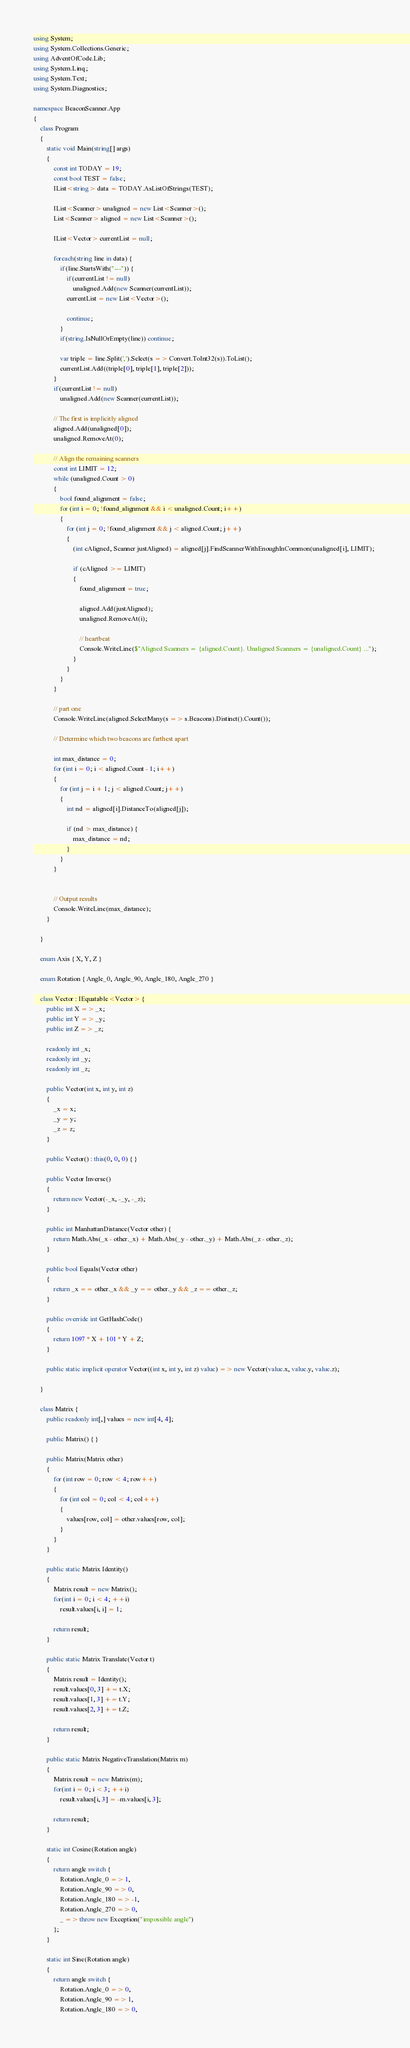Convert code to text. <code><loc_0><loc_0><loc_500><loc_500><_C#_>using System;
using System.Collections.Generic;
using AdventOfCode.Lib;
using System.Linq;
using System.Text;
using System.Diagnostics;

namespace BeaconScanner.App
{
    class Program
    {
        static void Main(string[] args)
        {
            const int TODAY = 19;
            const bool TEST = false;
            IList<string> data = TODAY.AsListOfStrings(TEST);

            IList<Scanner> unaligned = new List<Scanner>();
            List<Scanner> aligned = new List<Scanner>();

            IList<Vector> currentList = null;

            foreach(string line in data) {
                if(line.StartsWith("---")) {
                    if(currentList != null)
                        unaligned.Add(new Scanner(currentList));
                    currentList = new List<Vector>();
                    
                    continue;
                }
                if(string.IsNullOrEmpty(line)) continue;

                var triple = line.Split(',').Select(s => Convert.ToInt32(s)).ToList();
                currentList.Add((triple[0], triple[1], triple[2]));
            }
            if(currentList != null)
                unaligned.Add(new Scanner(currentList));

            // The first is implicitly aligned 
            aligned.Add(unaligned[0]);
            unaligned.RemoveAt(0);

            // Align the remaining scanners
            const int LIMIT = 12;
            while (unaligned.Count > 0)
            {
                bool found_alignment = false;
                for (int i = 0; !found_alignment && i < unaligned.Count; i++)
                {
                    for (int j = 0; !found_alignment && j < aligned.Count; j++)
                    {
                        (int cAligned, Scanner justAligned) = aligned[j].FindScannerWithEnoughInCommon(unaligned[i], LIMIT);

                        if (cAligned >= LIMIT)
                        {
                            found_alignment = true;

                            aligned.Add(justAligned);
                            unaligned.RemoveAt(i);

                            // heartbeat
                            Console.WriteLine($"Aligned Scanners = {aligned.Count}. Unaligned Scanners = {unaligned.Count} ...");
                        }
                    }
                }
            }

            // part one
            Console.WriteLine(aligned.SelectMany(s => s.Beacons).Distinct().Count());

            // Determine which two beacons are farthest apart

            int max_distance = 0;
            for (int i = 0; i < aligned.Count - 1; i++)
            {
                for (int j = i + 1; j < aligned.Count; j++)
                {
                    int nd = aligned[i].DistanceTo(aligned[j]);

                    if (nd > max_distance) {
                        max_distance = nd;
                    }
                }
            }


            // Output results
            Console.WriteLine(max_distance);
        }

    }

    enum Axis { X, Y, Z }

    enum Rotation { Angle_0, Angle_90, Angle_180, Angle_270 }
    
    class Vector : IEquatable<Vector> { 
        public int X => _x;
        public int Y => _y;
        public int Z => _z;
        
        readonly int _x;
        readonly int _y;
        readonly int _z;

        public Vector(int x, int y, int z)
        {
            _x = x;
            _y = y;
            _z = z;
        }

        public Vector() : this(0, 0, 0) { }

        public Vector Inverse()
        {
            return new Vector(-_x, -_y, -_z);
        }

        public int ManhattanDistance(Vector other) {
            return Math.Abs(_x - other._x) + Math.Abs(_y - other._y) + Math.Abs(_z - other._z);
        }

        public bool Equals(Vector other)
        {
            return _x == other._x && _y == other._y && _z == other._z;
        }

        public override int GetHashCode()
        {
            return 1097 * X + 101 * Y + Z;
        }

        public static implicit operator Vector((int x, int y, int z) value) => new Vector(value.x, value.y, value.z);
        
    }

    class Matrix {
        public readonly int[,] values = new int[4, 4];

        public Matrix() { }

        public Matrix(Matrix other)
        {
            for (int row = 0; row < 4; row++)
            {
                for (int col = 0; col < 4; col++)
                {
                    values[row, col] = other.values[row, col];
                }
            }
        }
        
        public static Matrix Identity()
        {
            Matrix result = new Matrix();
            for(int i = 0; i < 4; ++i) 
                result.values[i, i] = 1;

            return result;
        }

        public static Matrix Translate(Vector t)
        {
            Matrix result = Identity();
            result.values[0, 3] += t.X;
            result.values[1, 3] += t.Y;
            result.values[2, 3] += t.Z;

            return result;
        }

        public static Matrix NegativeTranslation(Matrix m)
        {
            Matrix result = new Matrix(m);
            for(int i = 0; i < 3; ++i)
                result.values[i, 3] = -m.values[i, 3];
            
            return result;
        }

        static int Cosine(Rotation angle)
        {
            return angle switch {
                Rotation.Angle_0 => 1,
                Rotation.Angle_90 => 0,
                Rotation.Angle_180 => -1,
                Rotation.Angle_270 => 0,
                _ => throw new Exception("impossible angle")
            };
        }

        static int Sine(Rotation angle)
        {
            return angle switch {
                Rotation.Angle_0 => 0,
                Rotation.Angle_90 => 1,
                Rotation.Angle_180 => 0,</code> 